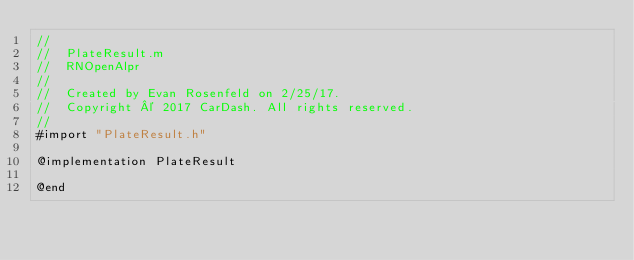<code> <loc_0><loc_0><loc_500><loc_500><_ObjectiveC_>//
//  PlateResult.m
//  RNOpenAlpr
//
//  Created by Evan Rosenfeld on 2/25/17.
//  Copyright © 2017 CarDash. All rights reserved.
//
#import "PlateResult.h"

@implementation PlateResult

@end
</code> 